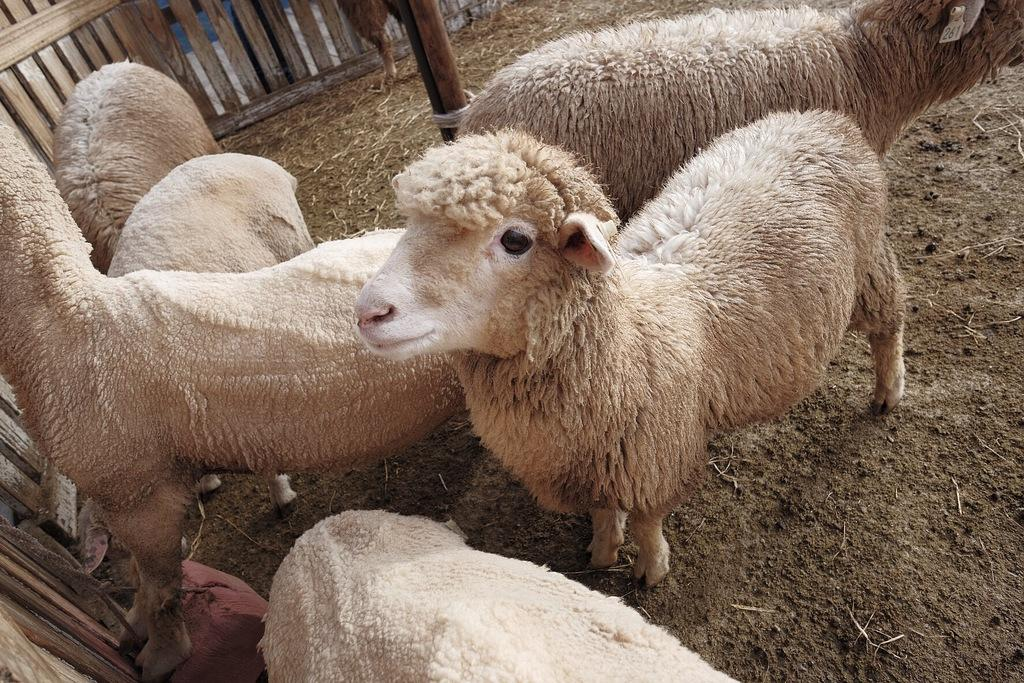How many sheep are visible in the image? There are six sheep in the foreground of the image. What is the position of the sheep in relation to the ground? The sheep are on the ground. What can be seen in the background of the image? There is a pole and railing in the background of the image. What type of orange tree can be seen in the image? There is no orange tree present in the image; it features six sheep on the ground with a pole and railing in the background. Can you describe the coastline visible in the image? There is no coastline visible in the image; it features six sheep on the ground with a pole and railing in the background. 